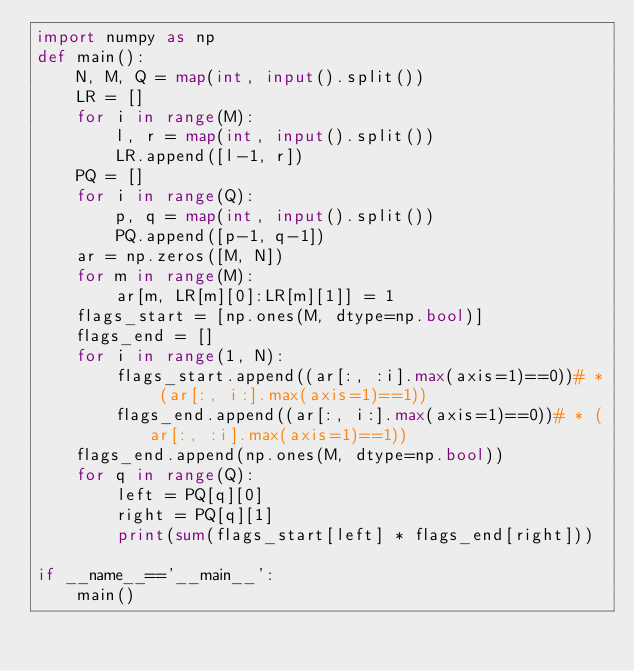Convert code to text. <code><loc_0><loc_0><loc_500><loc_500><_Python_>import numpy as np
def main():
    N, M, Q = map(int, input().split())
    LR = []
    for i in range(M):
        l, r = map(int, input().split())
        LR.append([l-1, r])
    PQ = []
    for i in range(Q):
        p, q = map(int, input().split())
        PQ.append([p-1, q-1])
    ar = np.zeros([M, N])
    for m in range(M):
        ar[m, LR[m][0]:LR[m][1]] = 1
    flags_start = [np.ones(M, dtype=np.bool)]
    flags_end = []
    for i in range(1, N):
        flags_start.append((ar[:, :i].max(axis=1)==0))# * (ar[:, i:].max(axis=1)==1))
        flags_end.append((ar[:, i:].max(axis=1)==0))# * (ar[:, :i].max(axis=1)==1))
    flags_end.append(np.ones(M, dtype=np.bool))
    for q in range(Q):
        left = PQ[q][0]
        right = PQ[q][1]
        print(sum(flags_start[left] * flags_end[right]))

if __name__=='__main__':
    main()</code> 